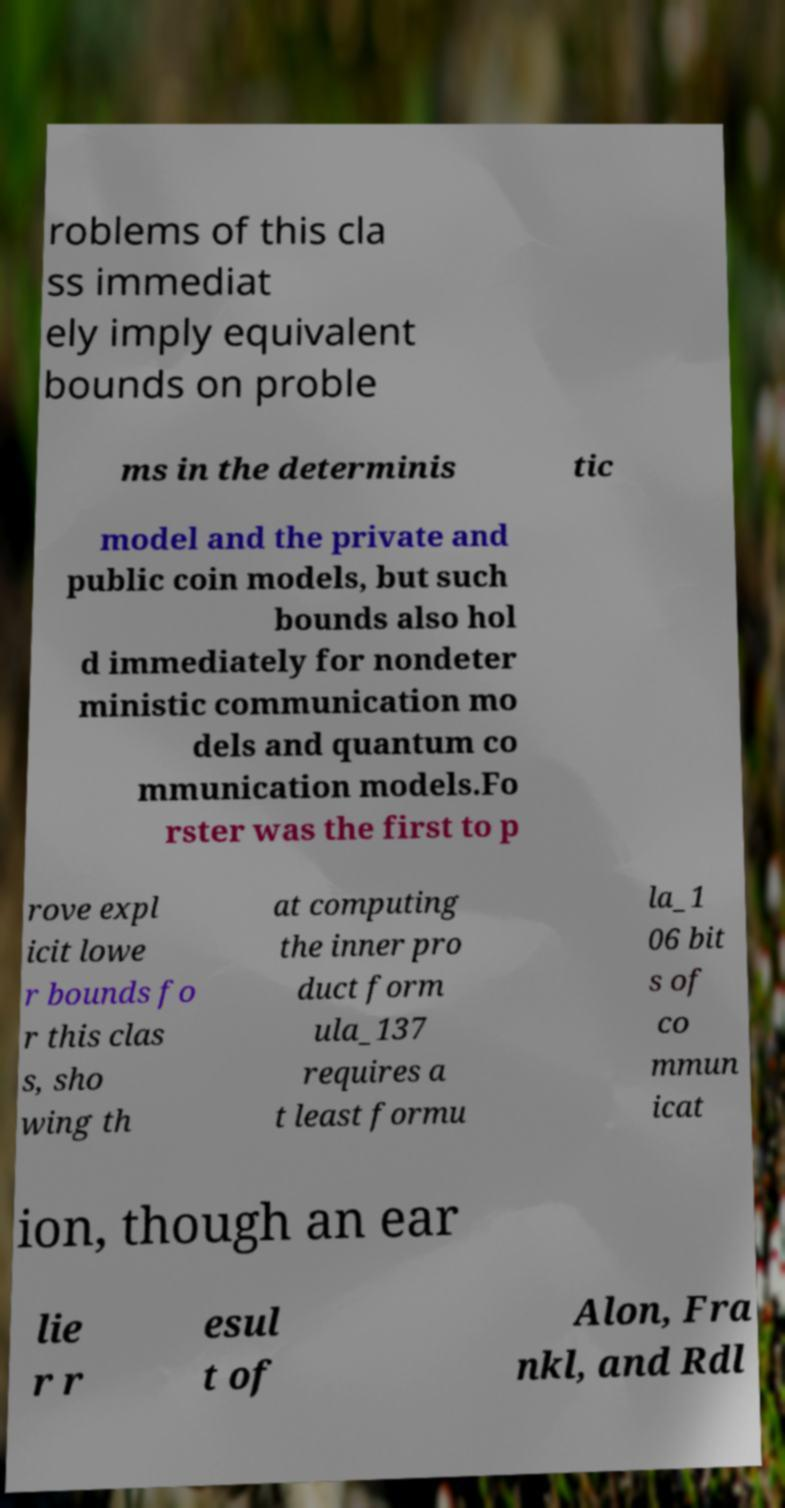Please identify and transcribe the text found in this image. roblems of this cla ss immediat ely imply equivalent bounds on proble ms in the determinis tic model and the private and public coin models, but such bounds also hol d immediately for nondeter ministic communication mo dels and quantum co mmunication models.Fo rster was the first to p rove expl icit lowe r bounds fo r this clas s, sho wing th at computing the inner pro duct form ula_137 requires a t least formu la_1 06 bit s of co mmun icat ion, though an ear lie r r esul t of Alon, Fra nkl, and Rdl 